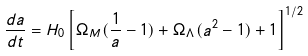Convert formula to latex. <formula><loc_0><loc_0><loc_500><loc_500>\frac { d a } { d t } = H _ { 0 } \left [ \Omega _ { M } ( \frac { 1 } { a } - 1 ) + \Omega _ { \Lambda } ( a ^ { 2 } - 1 ) + 1 \right ] ^ { 1 / 2 }</formula> 